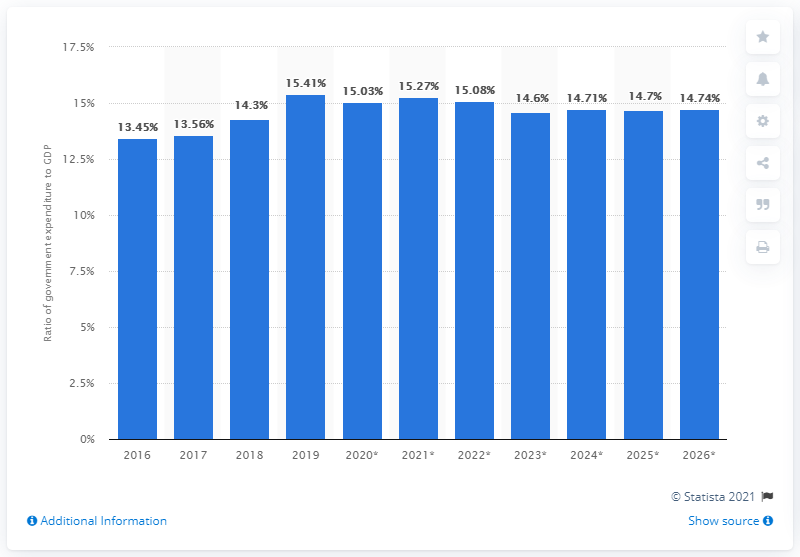Specify some key components in this picture. In 2019, government expenditure in Bangladesh accounted for 15.27% of the country's Gross Domestic Product (GDP). 